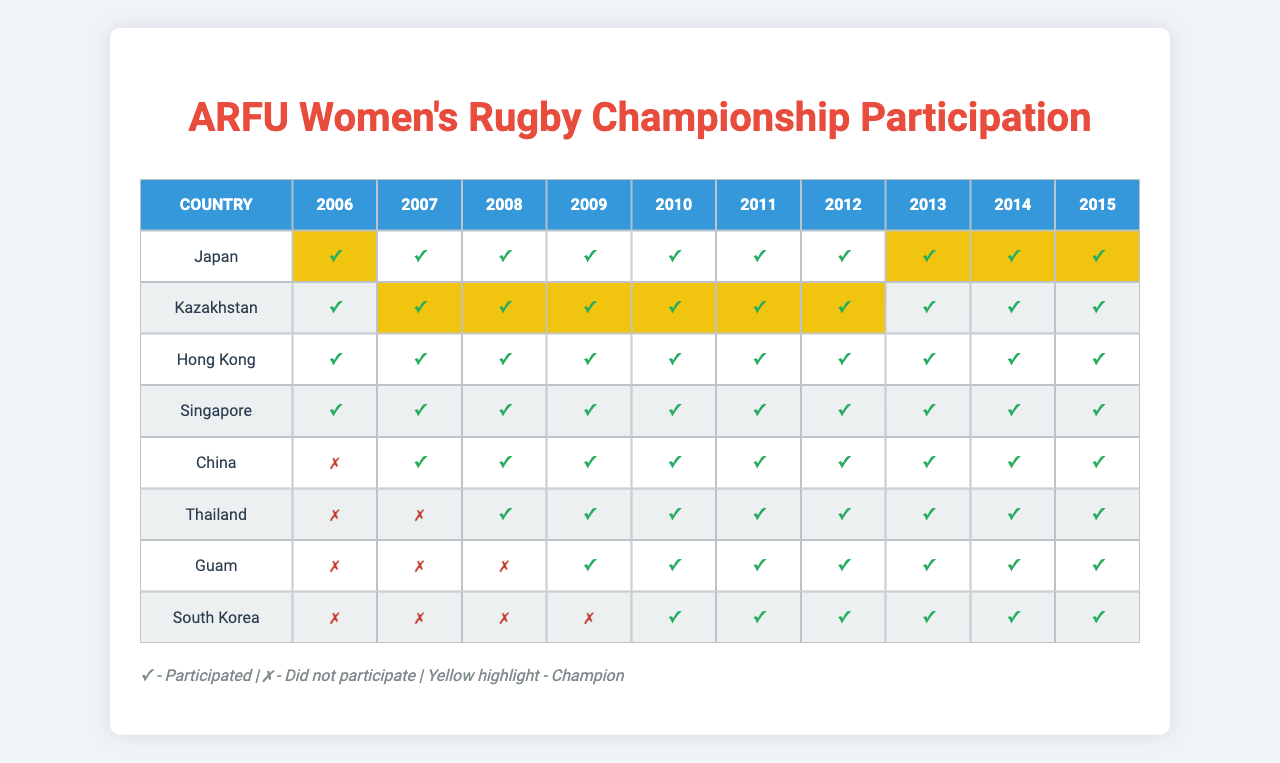What year did China first participate in the ARFU Women's Rugby Championship? In the participation data, China has a '1' in the year 2010, indicating its first participation.
Answer: 2010 How many years did Thailand participate in the ARFU Women's Rugby Championship? By examining the participation row for Thailand, '1's mark its participation in years 2008 to 2015, resulting in a total of 8 years.
Answer: 8 years Did Guam ever win the ARFU Women's Rugby Championship? Looking at the champions row, Guam is not mentioned as a champion in any year.
Answer: No Which country participated in the most championships during the recorded years? Japan shows '1's for all years from 2006 to 2015, indicating participation in 10 championships, which is the highest.
Answer: Japan During which years did South Korea not participate? South Korea has '0's for the years 2006 and 2007, meaning it did not participate in those two years.
Answer: 2006 and 2007 What is the percentage of participation for all countries in 2009? All countries participated in 2009, leading to 100% participation (8 out of 8).
Answer: 100% How many total championships did Kazakhstan win? Kazakhstan is marked as the champion for the years 2007 to 2011, winning a total of 5 championships.
Answer: 5 Which two countries had the least participation in the championships? By analyzing the participation data, Guam and Thailand had the least participation, as both had '0's in the earlier years.
Answer: Guam and Thailand In which years did Japan win the championship? Upon reviewing the champions, Japan won in the years 2013, 2014, and 2015.
Answer: 2013, 2014, and 2015 If the countries were ranked by the number of championships won, which position would China hold? China has never won a championship, and thus it holds the last position in this ranking.
Answer: Last position What was the trend in participation for South Korea over the years? South Korea's participation improved over the years, as it started with non-participation in 2006 and 2007 but participated from 2008 to 2015.
Answer: Improving trend 